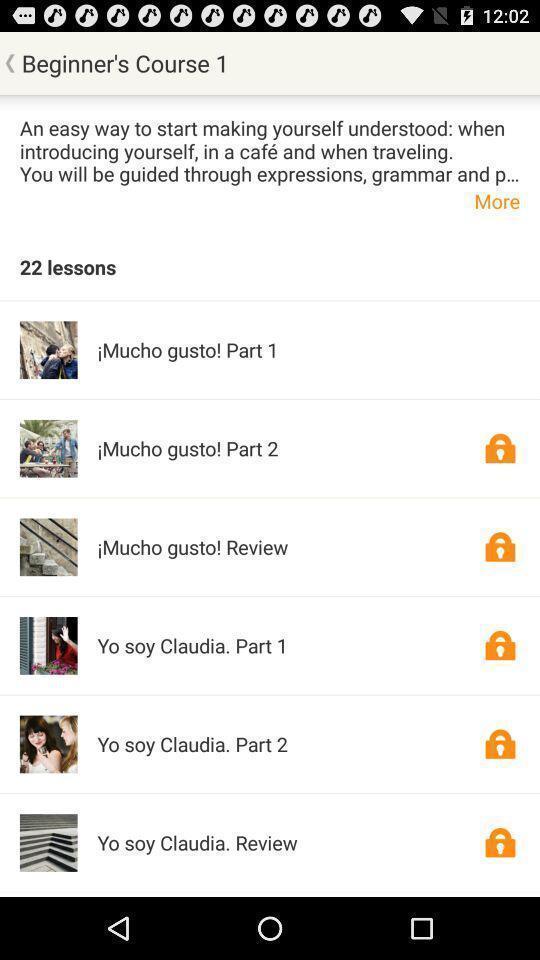Give me a narrative description of this picture. Page showing list of courses in app. 